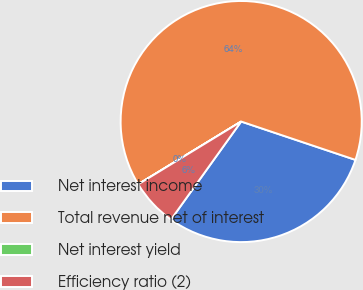Convert chart. <chart><loc_0><loc_0><loc_500><loc_500><pie_chart><fcel>Net interest income<fcel>Total revenue net of interest<fcel>Net interest yield<fcel>Efficiency ratio (2)<nl><fcel>29.74%<fcel>63.86%<fcel>0.01%<fcel>6.39%<nl></chart> 